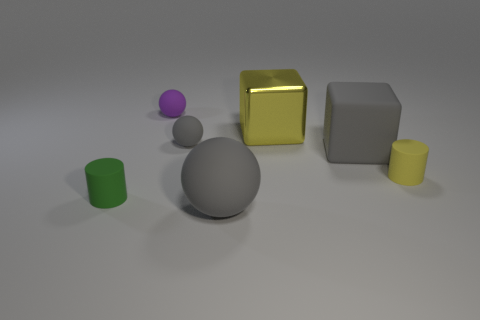What materials do these objects appear to be made of? The larger gray sphere has a matte finish that suggests it could be made of a material like stone or unpolished metal. The yellow cube looks metallic and shiny, perhaps like polished gold or brass. The small green cylinder seems to have a matte texture, possibly similar to plastic or painted wood. 